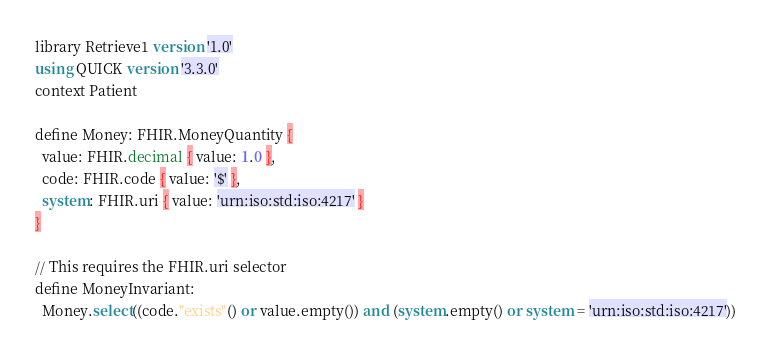Convert code to text. <code><loc_0><loc_0><loc_500><loc_500><_SQL_>library Retrieve1 version '1.0'
using QUICK version '3.3.0'
context Patient

define Money: FHIR.MoneyQuantity {
  value: FHIR.decimal { value: 1.0 },
  code: FHIR.code { value: '$' },
  system: FHIR.uri { value: 'urn:iso:std:iso:4217' }
}

// This requires the FHIR.uri selector
define MoneyInvariant:
  Money.select((code."exists"() or value.empty()) and (system.empty() or system = 'urn:iso:std:iso:4217'))
</code> 